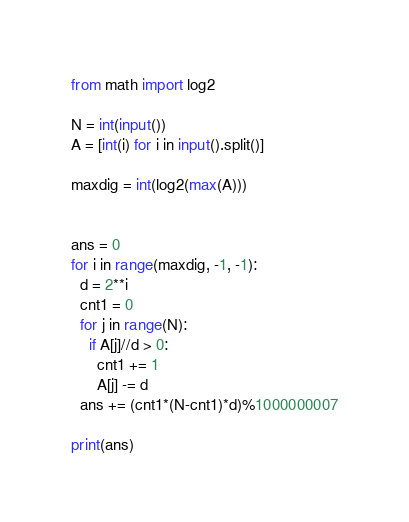Convert code to text. <code><loc_0><loc_0><loc_500><loc_500><_Python_>from math import log2

N = int(input())
A = [int(i) for i in input().split()]

maxdig = int(log2(max(A)))


ans = 0
for i in range(maxdig, -1, -1):
  d = 2**i
  cnt1 = 0
  for j in range(N):
    if A[j]//d > 0:
      cnt1 += 1
      A[j] -= d
  ans += (cnt1*(N-cnt1)*d)%1000000007

print(ans)</code> 